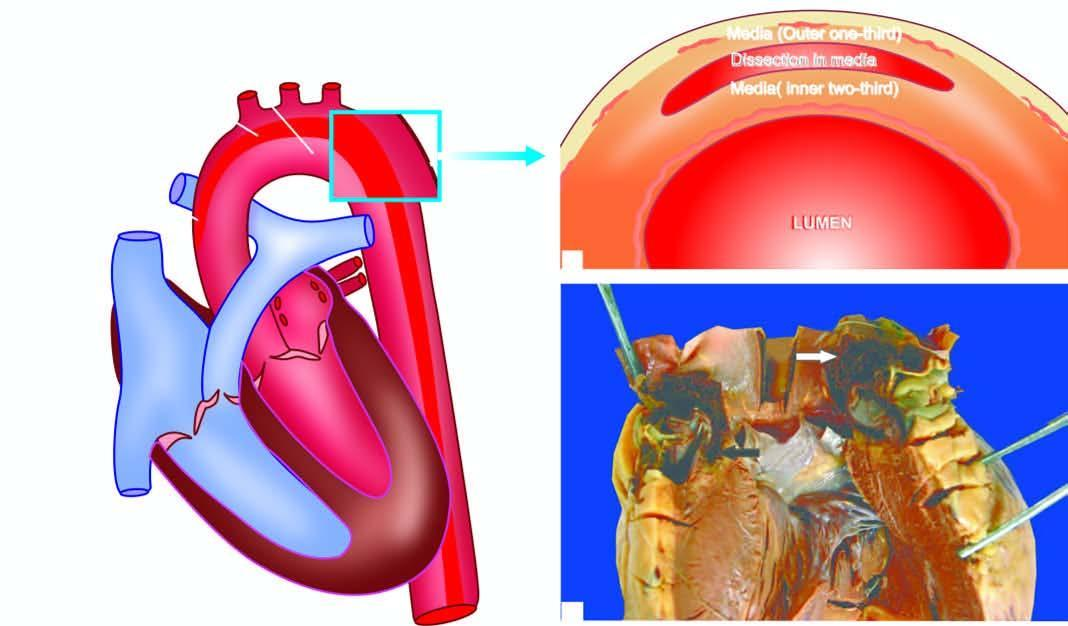s an intimal tear seen in the arch?
Answer the question using a single word or phrase. Yes 